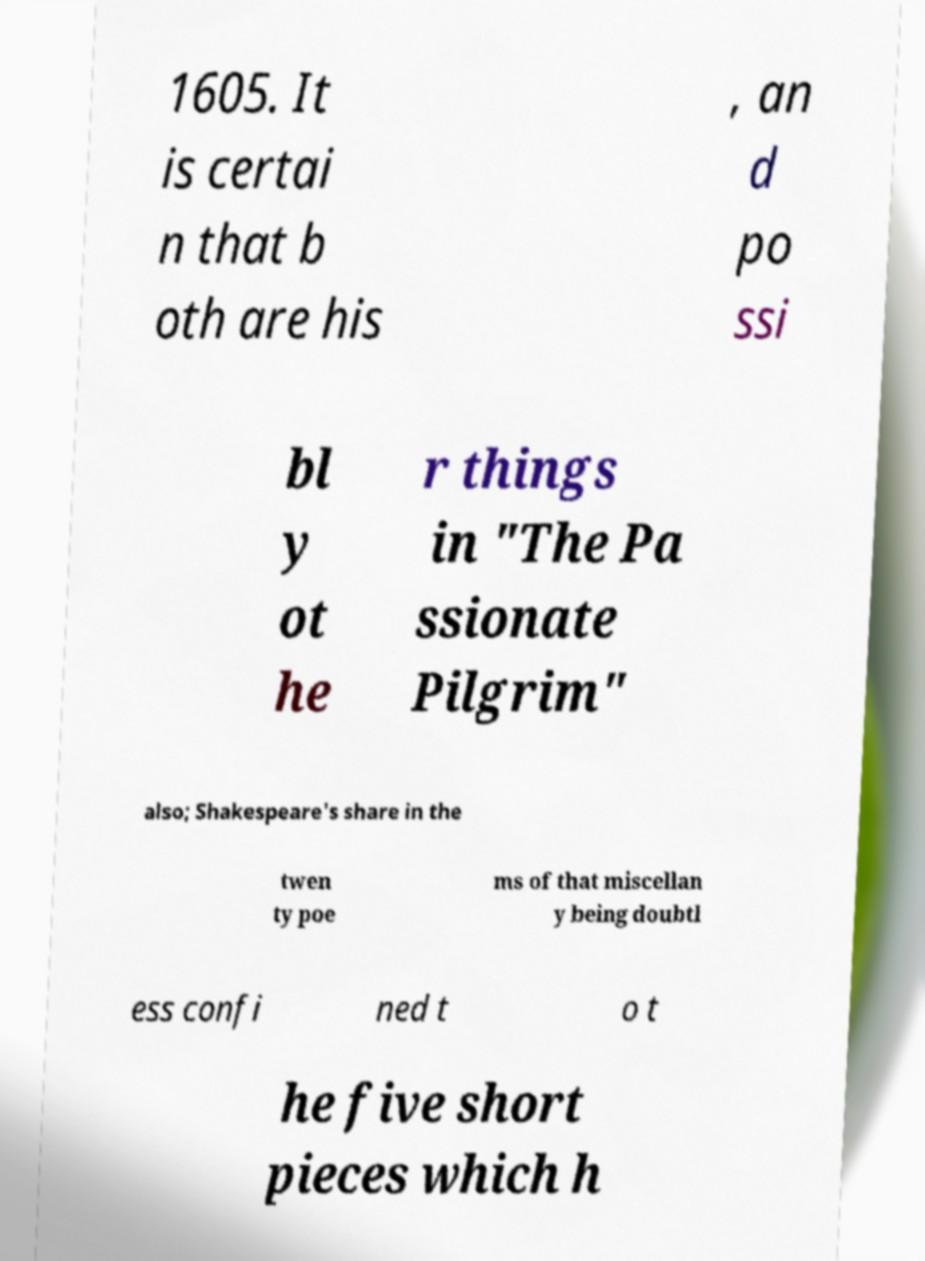What messages or text are displayed in this image? I need them in a readable, typed format. 1605. It is certai n that b oth are his , an d po ssi bl y ot he r things in "The Pa ssionate Pilgrim" also; Shakespeare's share in the twen ty poe ms of that miscellan y being doubtl ess confi ned t o t he five short pieces which h 